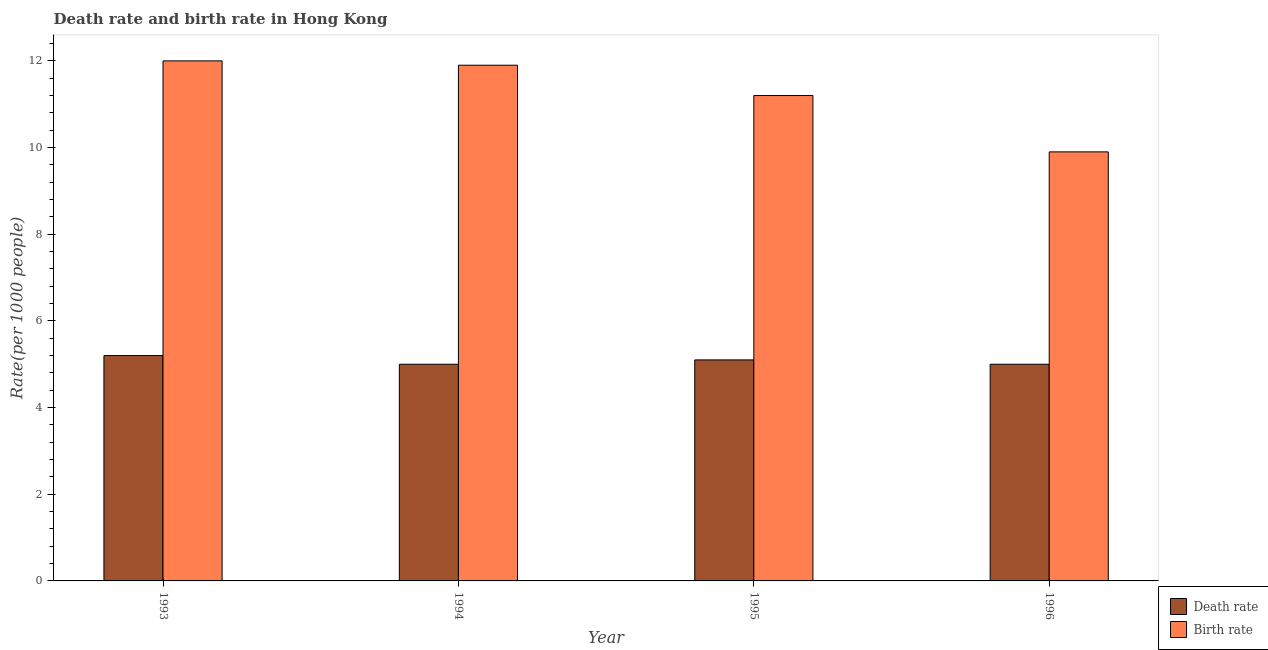How many groups of bars are there?
Provide a succinct answer. 4. How many bars are there on the 4th tick from the left?
Provide a short and direct response. 2. How many bars are there on the 4th tick from the right?
Offer a terse response. 2. What is the birth rate in 1995?
Ensure brevity in your answer.  11.2. Across all years, what is the minimum birth rate?
Your answer should be compact. 9.9. In which year was the death rate maximum?
Offer a very short reply. 1993. What is the total death rate in the graph?
Ensure brevity in your answer.  20.3. What is the difference between the death rate in 1993 and that in 1996?
Your answer should be compact. 0.2. What is the difference between the birth rate in 1996 and the death rate in 1995?
Your answer should be very brief. -1.3. What is the average birth rate per year?
Make the answer very short. 11.25. In how many years, is the birth rate greater than 12?
Make the answer very short. 0. Is the difference between the death rate in 1995 and 1996 greater than the difference between the birth rate in 1995 and 1996?
Keep it short and to the point. No. What is the difference between the highest and the second highest death rate?
Offer a terse response. 0.1. What is the difference between the highest and the lowest death rate?
Your answer should be very brief. 0.2. What does the 1st bar from the left in 1995 represents?
Offer a very short reply. Death rate. What does the 1st bar from the right in 1995 represents?
Your response must be concise. Birth rate. How many bars are there?
Give a very brief answer. 8. Are all the bars in the graph horizontal?
Give a very brief answer. No. Does the graph contain any zero values?
Your response must be concise. No. Does the graph contain grids?
Offer a very short reply. No. How are the legend labels stacked?
Keep it short and to the point. Vertical. What is the title of the graph?
Make the answer very short. Death rate and birth rate in Hong Kong. Does "Frequency of shipment arrival" appear as one of the legend labels in the graph?
Offer a very short reply. No. What is the label or title of the X-axis?
Ensure brevity in your answer.  Year. What is the label or title of the Y-axis?
Your response must be concise. Rate(per 1000 people). What is the Rate(per 1000 people) of Birth rate in 1993?
Give a very brief answer. 12. What is the Rate(per 1000 people) of Death rate in 1994?
Give a very brief answer. 5. What is the Rate(per 1000 people) in Birth rate in 1994?
Provide a succinct answer. 11.9. Across all years, what is the maximum Rate(per 1000 people) in Birth rate?
Your answer should be very brief. 12. Across all years, what is the minimum Rate(per 1000 people) of Death rate?
Provide a short and direct response. 5. Across all years, what is the minimum Rate(per 1000 people) of Birth rate?
Give a very brief answer. 9.9. What is the total Rate(per 1000 people) in Death rate in the graph?
Make the answer very short. 20.3. What is the total Rate(per 1000 people) in Birth rate in the graph?
Offer a terse response. 45. What is the difference between the Rate(per 1000 people) of Death rate in 1993 and that in 1994?
Your response must be concise. 0.2. What is the difference between the Rate(per 1000 people) in Birth rate in 1993 and that in 1994?
Ensure brevity in your answer.  0.1. What is the difference between the Rate(per 1000 people) in Death rate in 1993 and that in 1995?
Offer a very short reply. 0.1. What is the difference between the Rate(per 1000 people) in Birth rate in 1993 and that in 1995?
Keep it short and to the point. 0.8. What is the difference between the Rate(per 1000 people) of Death rate in 1993 and that in 1996?
Your answer should be very brief. 0.2. What is the difference between the Rate(per 1000 people) in Death rate in 1994 and that in 1996?
Provide a short and direct response. 0. What is the difference between the Rate(per 1000 people) of Birth rate in 1994 and that in 1996?
Your answer should be compact. 2. What is the difference between the Rate(per 1000 people) in Birth rate in 1995 and that in 1996?
Your answer should be very brief. 1.3. What is the difference between the Rate(per 1000 people) of Death rate in 1994 and the Rate(per 1000 people) of Birth rate in 1995?
Make the answer very short. -6.2. What is the difference between the Rate(per 1000 people) of Death rate in 1994 and the Rate(per 1000 people) of Birth rate in 1996?
Ensure brevity in your answer.  -4.9. What is the average Rate(per 1000 people) of Death rate per year?
Your answer should be compact. 5.08. What is the average Rate(per 1000 people) in Birth rate per year?
Provide a succinct answer. 11.25. In the year 1993, what is the difference between the Rate(per 1000 people) in Death rate and Rate(per 1000 people) in Birth rate?
Make the answer very short. -6.8. In the year 1994, what is the difference between the Rate(per 1000 people) of Death rate and Rate(per 1000 people) of Birth rate?
Offer a terse response. -6.9. In the year 1996, what is the difference between the Rate(per 1000 people) of Death rate and Rate(per 1000 people) of Birth rate?
Your answer should be compact. -4.9. What is the ratio of the Rate(per 1000 people) in Birth rate in 1993 to that in 1994?
Ensure brevity in your answer.  1.01. What is the ratio of the Rate(per 1000 people) in Death rate in 1993 to that in 1995?
Ensure brevity in your answer.  1.02. What is the ratio of the Rate(per 1000 people) of Birth rate in 1993 to that in 1995?
Ensure brevity in your answer.  1.07. What is the ratio of the Rate(per 1000 people) of Death rate in 1993 to that in 1996?
Your response must be concise. 1.04. What is the ratio of the Rate(per 1000 people) in Birth rate in 1993 to that in 1996?
Your response must be concise. 1.21. What is the ratio of the Rate(per 1000 people) of Death rate in 1994 to that in 1995?
Keep it short and to the point. 0.98. What is the ratio of the Rate(per 1000 people) in Birth rate in 1994 to that in 1996?
Provide a succinct answer. 1.2. What is the ratio of the Rate(per 1000 people) of Birth rate in 1995 to that in 1996?
Provide a short and direct response. 1.13. What is the difference between the highest and the second highest Rate(per 1000 people) of Death rate?
Offer a terse response. 0.1. What is the difference between the highest and the lowest Rate(per 1000 people) in Death rate?
Give a very brief answer. 0.2. 